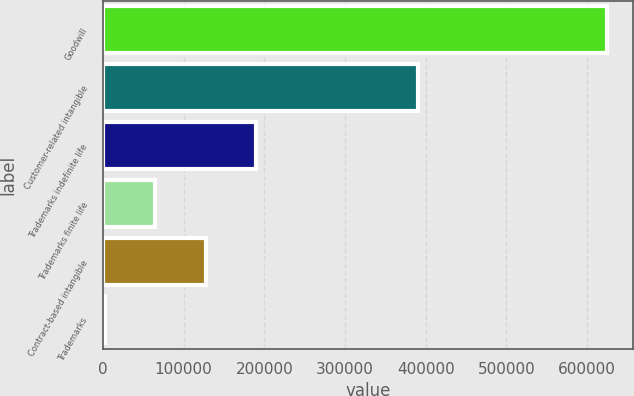<chart> <loc_0><loc_0><loc_500><loc_500><bar_chart><fcel>Goodwill<fcel>Customer-related intangible<fcel>Trademarks indefinite life<fcel>Trademarks finite life<fcel>Contract-based intangible<fcel>Trademarks<nl><fcel>625120<fcel>390232<fcel>189352<fcel>64846.6<fcel>127099<fcel>2594<nl></chart> 